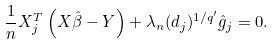<formula> <loc_0><loc_0><loc_500><loc_500>\frac { 1 } { n } X ^ { T } _ { j } \left ( X \hat { \beta } - Y \right ) + \lambda _ { n } ( d _ { j } ) ^ { 1 / q ^ { \prime } } \hat { g } _ { j } = 0 .</formula> 